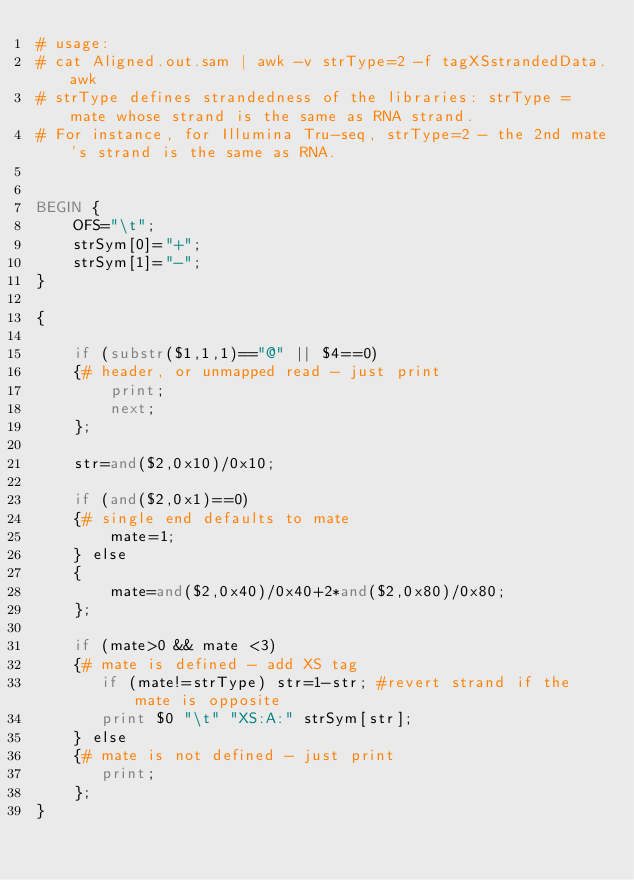Convert code to text. <code><loc_0><loc_0><loc_500><loc_500><_Awk_># usage:
# cat Aligned.out.sam | awk -v strType=2 -f tagXSstrandedData.awk 
# strType defines strandedness of the libraries: strType = mate whose strand is the same as RNA strand.
# For instance, for Illumina Tru-seq, strType=2 - the 2nd mate's strand is the same as RNA.


BEGIN {
    OFS="\t";
    strSym[0]="+";
    strSym[1]="-";
}

{

    if (substr($1,1,1)=="@" || $4==0)
    {# header, or unmapped read - just print
        print;
        next;
    };

    str=and($2,0x10)/0x10;
   
    if (and($2,0x1)==0)
    {# single end defaults to mate
        mate=1;
    } else
    {
        mate=and($2,0x40)/0x40+2*and($2,0x80)/0x80;
    };

    if (mate>0 && mate <3)
    {# mate is defined - add XS tag
       if (mate!=strType) str=1-str; #revert strand if the mate is opposite
       print $0 "\t" "XS:A:" strSym[str];
    } else 
    {# mate is not defined - just print
       print;
    };    
}
</code> 